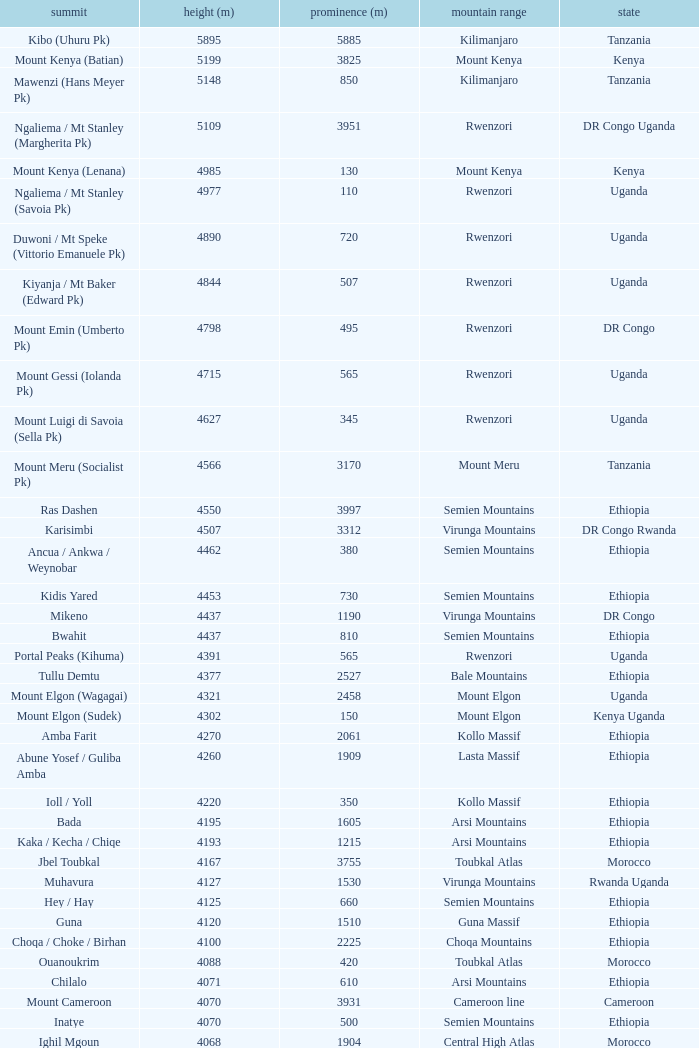Which Country has a Height (m) larger than 4100, and a Range of arsi mountains, and a Mountain of bada? Ethiopia. 